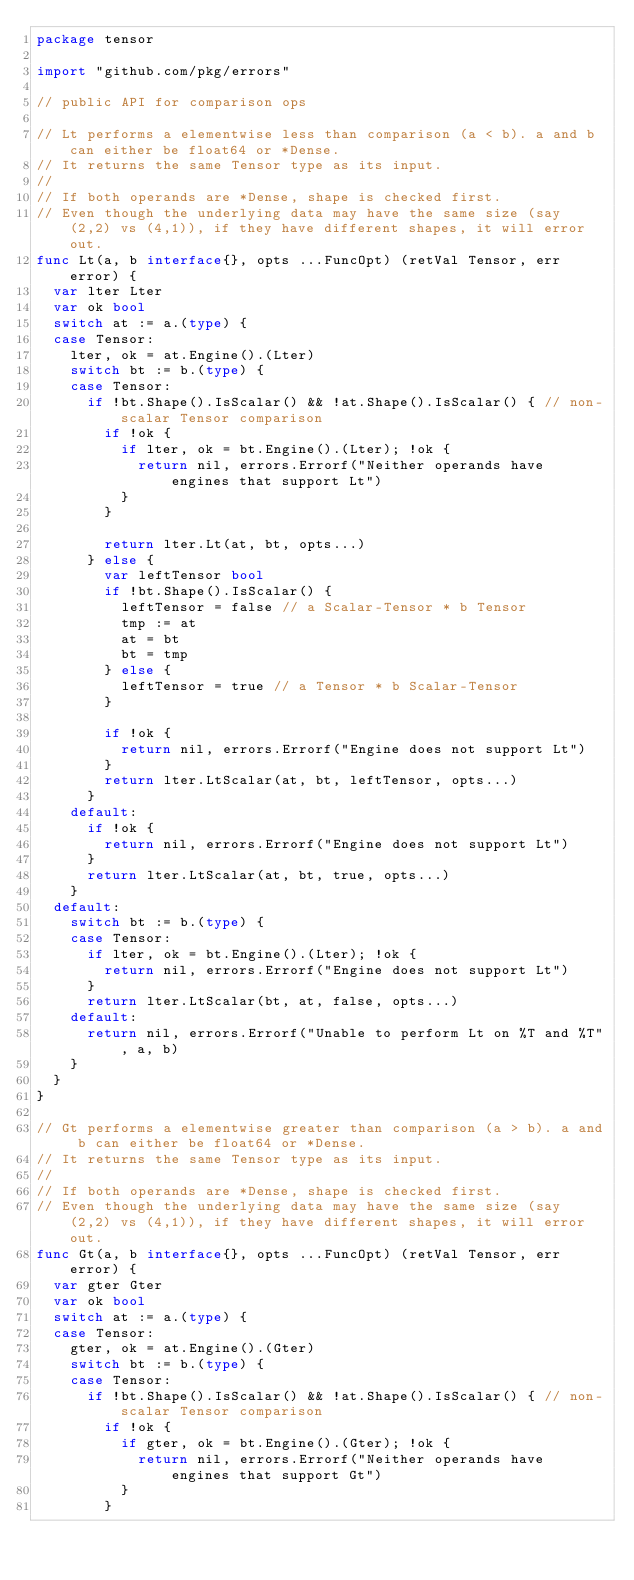<code> <loc_0><loc_0><loc_500><loc_500><_Go_>package tensor

import "github.com/pkg/errors"

// public API for comparison ops

// Lt performs a elementwise less than comparison (a < b). a and b can either be float64 or *Dense.
// It returns the same Tensor type as its input.
//
// If both operands are *Dense, shape is checked first.
// Even though the underlying data may have the same size (say (2,2) vs (4,1)), if they have different shapes, it will error out.
func Lt(a, b interface{}, opts ...FuncOpt) (retVal Tensor, err error) {
	var lter Lter
	var ok bool
	switch at := a.(type) {
	case Tensor:
		lter, ok = at.Engine().(Lter)
		switch bt := b.(type) {
		case Tensor:
			if !bt.Shape().IsScalar() && !at.Shape().IsScalar() { // non-scalar Tensor comparison
				if !ok {
					if lter, ok = bt.Engine().(Lter); !ok {
						return nil, errors.Errorf("Neither operands have engines that support Lt")
					}
				}

				return lter.Lt(at, bt, opts...)
			} else {
				var leftTensor bool
				if !bt.Shape().IsScalar() {
					leftTensor = false // a Scalar-Tensor * b Tensor
					tmp := at
					at = bt
					bt = tmp
				} else {
					leftTensor = true // a Tensor * b Scalar-Tensor
				}

				if !ok {
					return nil, errors.Errorf("Engine does not support Lt")
				}
				return lter.LtScalar(at, bt, leftTensor, opts...)
			}
		default:
			if !ok {
				return nil, errors.Errorf("Engine does not support Lt")
			}
			return lter.LtScalar(at, bt, true, opts...)
		}
	default:
		switch bt := b.(type) {
		case Tensor:
			if lter, ok = bt.Engine().(Lter); !ok {
				return nil, errors.Errorf("Engine does not support Lt")
			}
			return lter.LtScalar(bt, at, false, opts...)
		default:
			return nil, errors.Errorf("Unable to perform Lt on %T and %T", a, b)
		}
	}
}

// Gt performs a elementwise greater than comparison (a > b). a and b can either be float64 or *Dense.
// It returns the same Tensor type as its input.
//
// If both operands are *Dense, shape is checked first.
// Even though the underlying data may have the same size (say (2,2) vs (4,1)), if they have different shapes, it will error out.
func Gt(a, b interface{}, opts ...FuncOpt) (retVal Tensor, err error) {
	var gter Gter
	var ok bool
	switch at := a.(type) {
	case Tensor:
		gter, ok = at.Engine().(Gter)
		switch bt := b.(type) {
		case Tensor:
			if !bt.Shape().IsScalar() && !at.Shape().IsScalar() { // non-scalar Tensor comparison
				if !ok {
					if gter, ok = bt.Engine().(Gter); !ok {
						return nil, errors.Errorf("Neither operands have engines that support Gt")
					}
				}</code> 